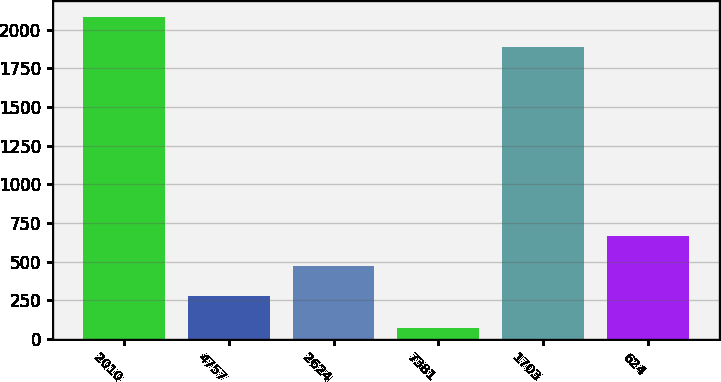<chart> <loc_0><loc_0><loc_500><loc_500><bar_chart><fcel>2010<fcel>4757<fcel>2624<fcel>7381<fcel>1703<fcel>624<nl><fcel>2077.9<fcel>278<fcel>471.9<fcel>69<fcel>1884<fcel>665.8<nl></chart> 